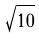Convert formula to latex. <formula><loc_0><loc_0><loc_500><loc_500>\sqrt { 1 0 }</formula> 